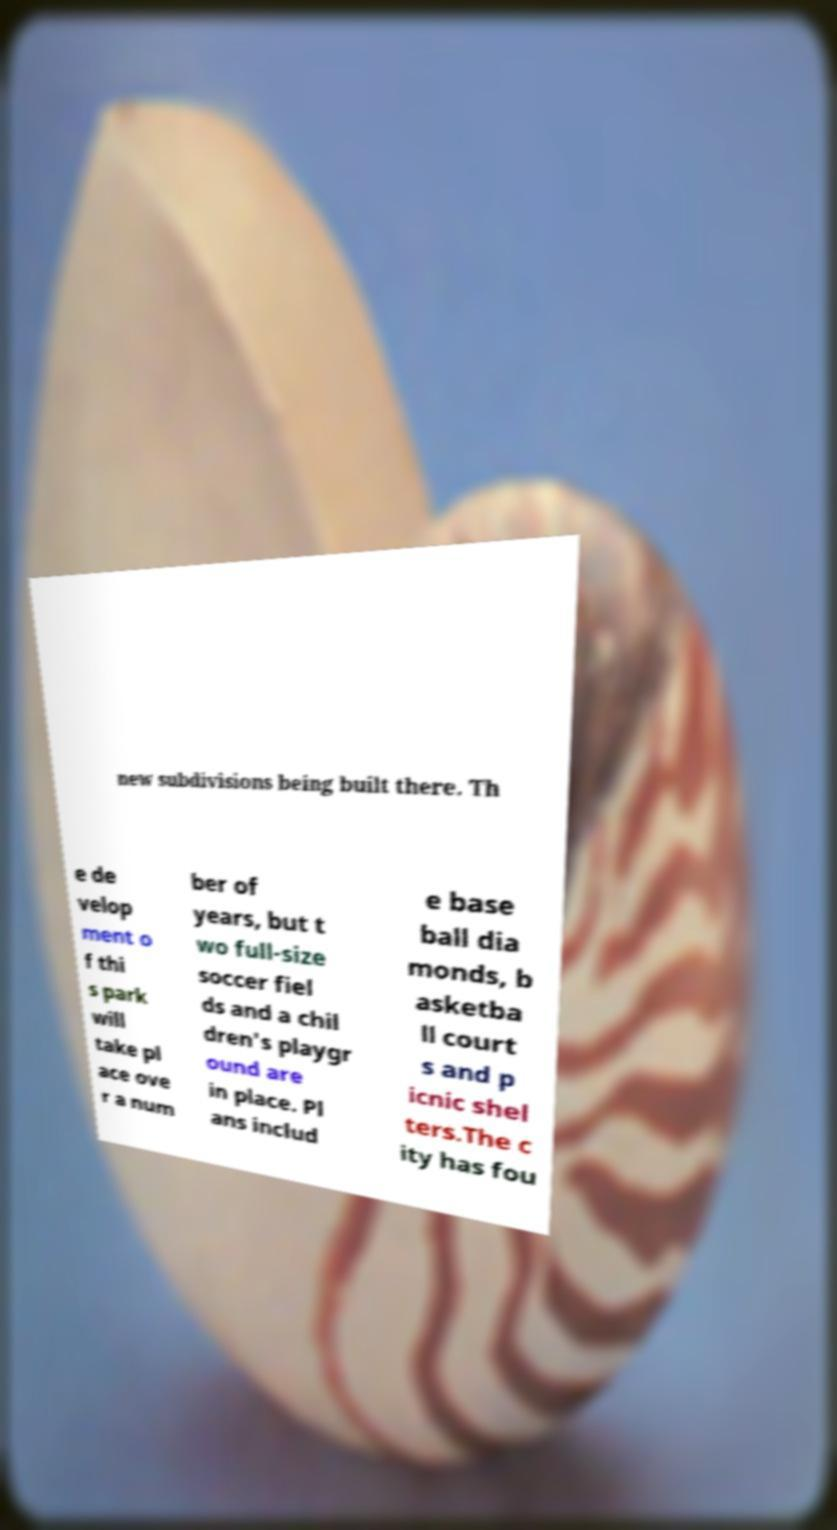Please read and relay the text visible in this image. What does it say? new subdivisions being built there. Th e de velop ment o f thi s park will take pl ace ove r a num ber of years, but t wo full-size soccer fiel ds and a chil dren's playgr ound are in place. Pl ans includ e base ball dia monds, b asketba ll court s and p icnic shel ters.The c ity has fou 